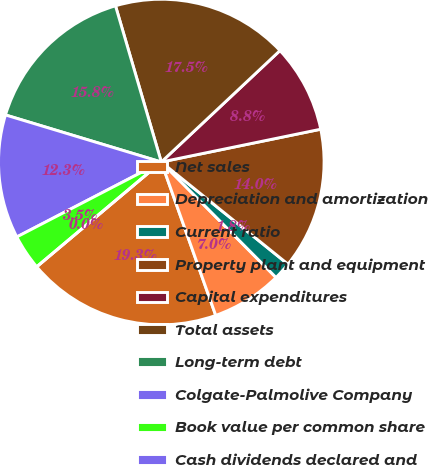<chart> <loc_0><loc_0><loc_500><loc_500><pie_chart><fcel>Net sales<fcel>Depreciation and amortization<fcel>Current ratio<fcel>Property plant and equipment<fcel>Capital expenditures<fcel>Total assets<fcel>Long-term debt<fcel>Colgate-Palmolive Company<fcel>Book value per common share<fcel>Cash dividends declared and<nl><fcel>19.3%<fcel>7.02%<fcel>1.75%<fcel>14.03%<fcel>8.77%<fcel>17.54%<fcel>15.79%<fcel>12.28%<fcel>3.51%<fcel>0.0%<nl></chart> 